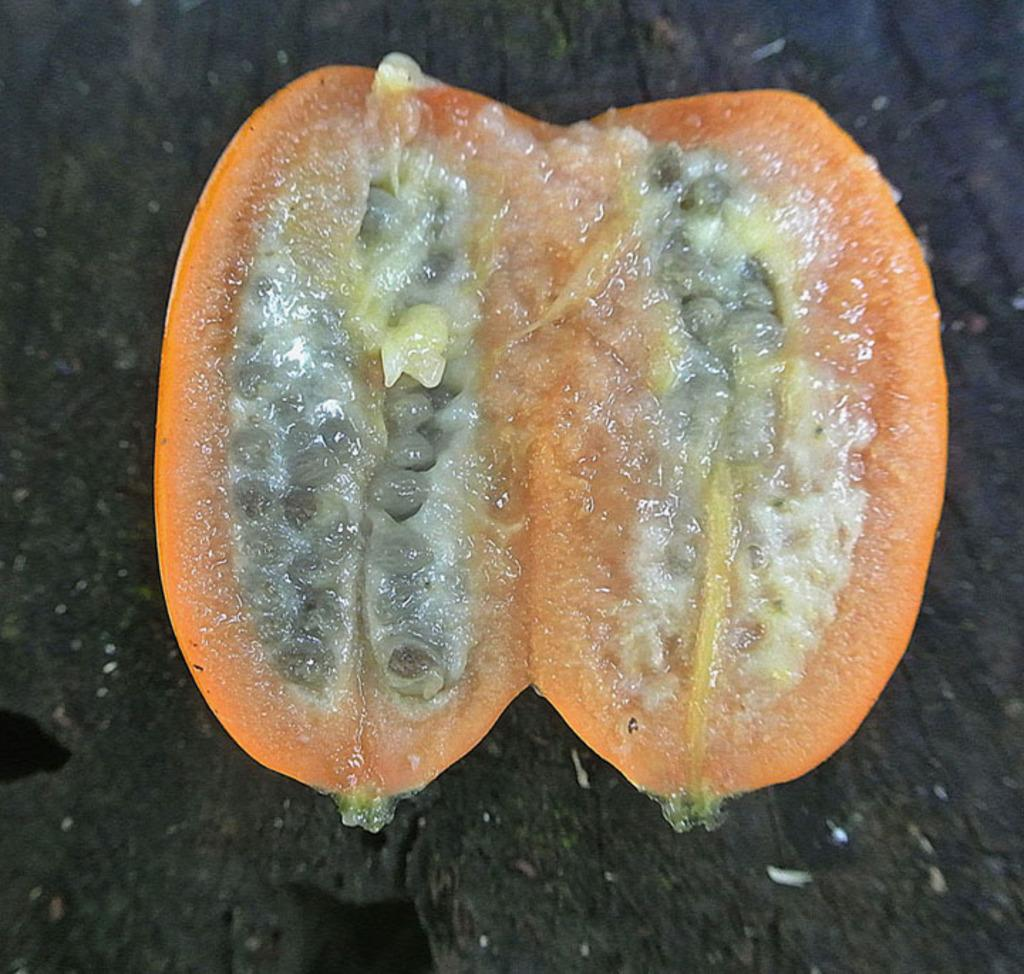What type of food is present in the image? There is a fruit in the image. What color is the background of the image? The background of the image is black. How many eggs are visible in the image? There are no eggs present in the image. What type of stamp can be seen on the fruit in the image? There is no stamp on the fruit in the image. 